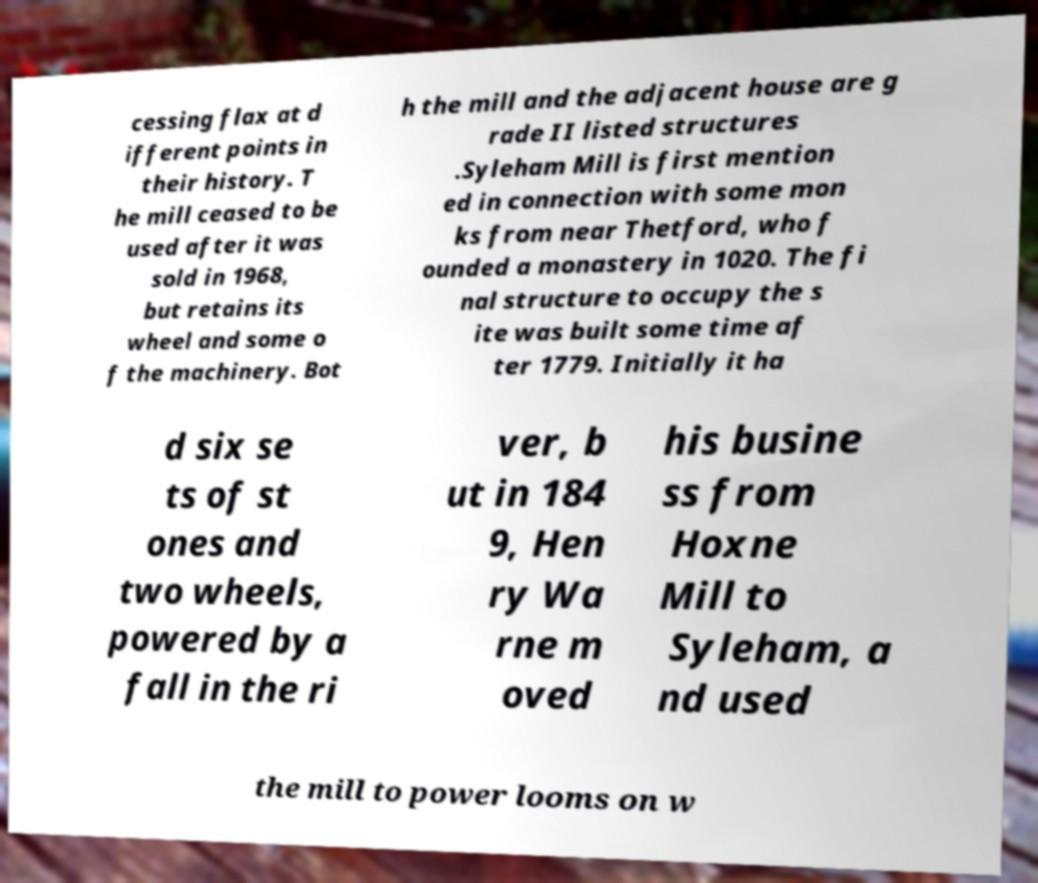For documentation purposes, I need the text within this image transcribed. Could you provide that? cessing flax at d ifferent points in their history. T he mill ceased to be used after it was sold in 1968, but retains its wheel and some o f the machinery. Bot h the mill and the adjacent house are g rade II listed structures .Syleham Mill is first mention ed in connection with some mon ks from near Thetford, who f ounded a monastery in 1020. The fi nal structure to occupy the s ite was built some time af ter 1779. Initially it ha d six se ts of st ones and two wheels, powered by a fall in the ri ver, b ut in 184 9, Hen ry Wa rne m oved his busine ss from Hoxne Mill to Syleham, a nd used the mill to power looms on w 